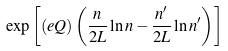<formula> <loc_0><loc_0><loc_500><loc_500>\exp \left [ ( e Q ) \left ( \frac { n } { 2 L } \ln { n } - \frac { n ^ { \prime } } { 2 L } \ln { n ^ { \prime } } \right ) \right ]</formula> 